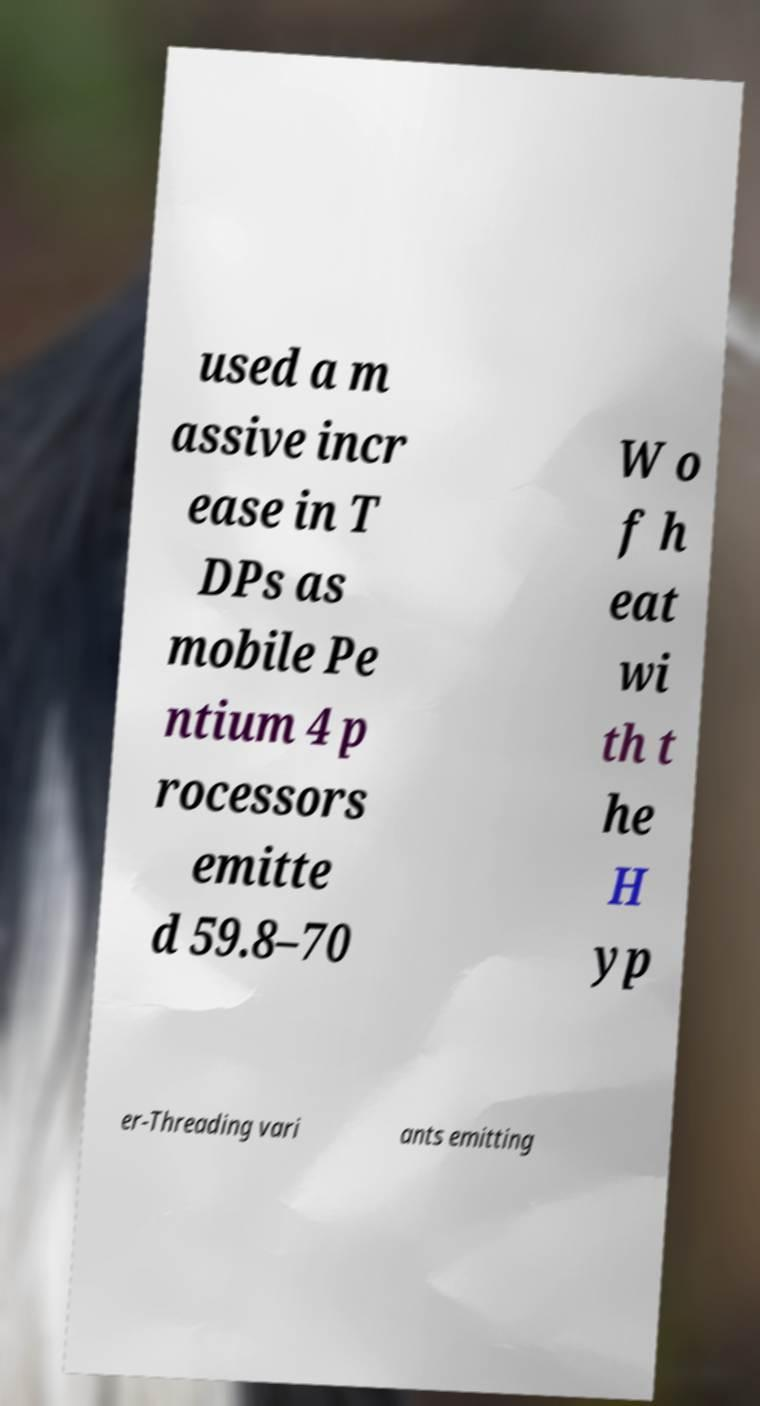Could you assist in decoding the text presented in this image and type it out clearly? used a m assive incr ease in T DPs as mobile Pe ntium 4 p rocessors emitte d 59.8–70 W o f h eat wi th t he H yp er-Threading vari ants emitting 